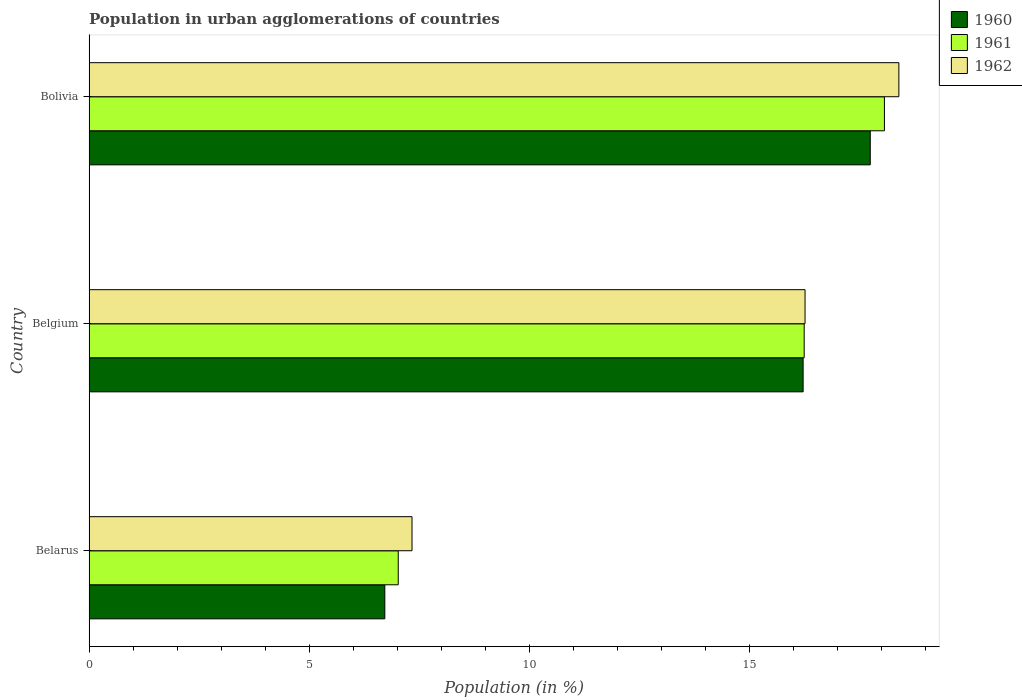How many different coloured bars are there?
Your response must be concise. 3. How many bars are there on the 2nd tick from the top?
Ensure brevity in your answer.  3. How many bars are there on the 2nd tick from the bottom?
Offer a terse response. 3. What is the label of the 3rd group of bars from the top?
Keep it short and to the point. Belarus. What is the percentage of population in urban agglomerations in 1962 in Bolivia?
Keep it short and to the point. 18.4. Across all countries, what is the maximum percentage of population in urban agglomerations in 1961?
Ensure brevity in your answer.  18.07. Across all countries, what is the minimum percentage of population in urban agglomerations in 1962?
Offer a very short reply. 7.34. In which country was the percentage of population in urban agglomerations in 1961 minimum?
Offer a very short reply. Belarus. What is the total percentage of population in urban agglomerations in 1962 in the graph?
Make the answer very short. 41.99. What is the difference between the percentage of population in urban agglomerations in 1960 in Belgium and that in Bolivia?
Provide a short and direct response. -1.53. What is the difference between the percentage of population in urban agglomerations in 1960 in Belarus and the percentage of population in urban agglomerations in 1962 in Belgium?
Ensure brevity in your answer.  -9.55. What is the average percentage of population in urban agglomerations in 1960 per country?
Offer a very short reply. 13.56. What is the difference between the percentage of population in urban agglomerations in 1962 and percentage of population in urban agglomerations in 1961 in Belgium?
Give a very brief answer. 0.02. What is the ratio of the percentage of population in urban agglomerations in 1961 in Belarus to that in Bolivia?
Offer a very short reply. 0.39. Is the percentage of population in urban agglomerations in 1961 in Belarus less than that in Bolivia?
Give a very brief answer. Yes. Is the difference between the percentage of population in urban agglomerations in 1962 in Belarus and Belgium greater than the difference between the percentage of population in urban agglomerations in 1961 in Belarus and Belgium?
Your answer should be very brief. Yes. What is the difference between the highest and the second highest percentage of population in urban agglomerations in 1961?
Your answer should be very brief. 1.82. What is the difference between the highest and the lowest percentage of population in urban agglomerations in 1961?
Provide a short and direct response. 11.04. What does the 2nd bar from the top in Belarus represents?
Ensure brevity in your answer.  1961. Is it the case that in every country, the sum of the percentage of population in urban agglomerations in 1960 and percentage of population in urban agglomerations in 1961 is greater than the percentage of population in urban agglomerations in 1962?
Your answer should be very brief. Yes. How many countries are there in the graph?
Your answer should be very brief. 3. What is the difference between two consecutive major ticks on the X-axis?
Keep it short and to the point. 5. Are the values on the major ticks of X-axis written in scientific E-notation?
Keep it short and to the point. No. Does the graph contain grids?
Make the answer very short. No. What is the title of the graph?
Your response must be concise. Population in urban agglomerations of countries. Does "1987" appear as one of the legend labels in the graph?
Provide a short and direct response. No. What is the Population (in %) of 1960 in Belarus?
Make the answer very short. 6.72. What is the Population (in %) in 1961 in Belarus?
Give a very brief answer. 7.02. What is the Population (in %) in 1962 in Belarus?
Your answer should be compact. 7.34. What is the Population (in %) of 1960 in Belgium?
Ensure brevity in your answer.  16.22. What is the Population (in %) in 1961 in Belgium?
Keep it short and to the point. 16.24. What is the Population (in %) in 1962 in Belgium?
Your answer should be compact. 16.26. What is the Population (in %) in 1960 in Bolivia?
Your answer should be very brief. 17.75. What is the Population (in %) in 1961 in Bolivia?
Your response must be concise. 18.07. What is the Population (in %) of 1962 in Bolivia?
Ensure brevity in your answer.  18.4. Across all countries, what is the maximum Population (in %) in 1960?
Provide a succinct answer. 17.75. Across all countries, what is the maximum Population (in %) in 1961?
Ensure brevity in your answer.  18.07. Across all countries, what is the maximum Population (in %) of 1962?
Provide a succinct answer. 18.4. Across all countries, what is the minimum Population (in %) in 1960?
Ensure brevity in your answer.  6.72. Across all countries, what is the minimum Population (in %) in 1961?
Keep it short and to the point. 7.02. Across all countries, what is the minimum Population (in %) of 1962?
Provide a succinct answer. 7.34. What is the total Population (in %) in 1960 in the graph?
Make the answer very short. 40.68. What is the total Population (in %) in 1961 in the graph?
Your answer should be very brief. 41.33. What is the total Population (in %) of 1962 in the graph?
Provide a short and direct response. 41.99. What is the difference between the Population (in %) of 1960 in Belarus and that in Belgium?
Make the answer very short. -9.5. What is the difference between the Population (in %) of 1961 in Belarus and that in Belgium?
Ensure brevity in your answer.  -9.22. What is the difference between the Population (in %) of 1962 in Belarus and that in Belgium?
Give a very brief answer. -8.93. What is the difference between the Population (in %) in 1960 in Belarus and that in Bolivia?
Offer a terse response. -11.03. What is the difference between the Population (in %) of 1961 in Belarus and that in Bolivia?
Provide a short and direct response. -11.04. What is the difference between the Population (in %) of 1962 in Belarus and that in Bolivia?
Offer a terse response. -11.06. What is the difference between the Population (in %) of 1960 in Belgium and that in Bolivia?
Keep it short and to the point. -1.53. What is the difference between the Population (in %) of 1961 in Belgium and that in Bolivia?
Make the answer very short. -1.82. What is the difference between the Population (in %) in 1962 in Belgium and that in Bolivia?
Give a very brief answer. -2.13. What is the difference between the Population (in %) in 1960 in Belarus and the Population (in %) in 1961 in Belgium?
Your answer should be compact. -9.53. What is the difference between the Population (in %) of 1960 in Belarus and the Population (in %) of 1962 in Belgium?
Make the answer very short. -9.55. What is the difference between the Population (in %) of 1961 in Belarus and the Population (in %) of 1962 in Belgium?
Your answer should be compact. -9.24. What is the difference between the Population (in %) in 1960 in Belarus and the Population (in %) in 1961 in Bolivia?
Offer a very short reply. -11.35. What is the difference between the Population (in %) in 1960 in Belarus and the Population (in %) in 1962 in Bolivia?
Provide a succinct answer. -11.68. What is the difference between the Population (in %) of 1961 in Belarus and the Population (in %) of 1962 in Bolivia?
Your answer should be very brief. -11.37. What is the difference between the Population (in %) in 1960 in Belgium and the Population (in %) in 1961 in Bolivia?
Give a very brief answer. -1.85. What is the difference between the Population (in %) in 1960 in Belgium and the Population (in %) in 1962 in Bolivia?
Keep it short and to the point. -2.18. What is the difference between the Population (in %) of 1961 in Belgium and the Population (in %) of 1962 in Bolivia?
Keep it short and to the point. -2.15. What is the average Population (in %) of 1960 per country?
Provide a succinct answer. 13.56. What is the average Population (in %) of 1961 per country?
Your answer should be compact. 13.78. What is the average Population (in %) of 1962 per country?
Your answer should be very brief. 14. What is the difference between the Population (in %) in 1960 and Population (in %) in 1961 in Belarus?
Keep it short and to the point. -0.3. What is the difference between the Population (in %) of 1960 and Population (in %) of 1962 in Belarus?
Offer a very short reply. -0.62. What is the difference between the Population (in %) of 1961 and Population (in %) of 1962 in Belarus?
Make the answer very short. -0.31. What is the difference between the Population (in %) of 1960 and Population (in %) of 1961 in Belgium?
Keep it short and to the point. -0.02. What is the difference between the Population (in %) of 1960 and Population (in %) of 1962 in Belgium?
Keep it short and to the point. -0.04. What is the difference between the Population (in %) in 1961 and Population (in %) in 1962 in Belgium?
Make the answer very short. -0.02. What is the difference between the Population (in %) of 1960 and Population (in %) of 1961 in Bolivia?
Make the answer very short. -0.32. What is the difference between the Population (in %) of 1960 and Population (in %) of 1962 in Bolivia?
Your answer should be compact. -0.65. What is the difference between the Population (in %) of 1961 and Population (in %) of 1962 in Bolivia?
Offer a terse response. -0.33. What is the ratio of the Population (in %) of 1960 in Belarus to that in Belgium?
Your answer should be compact. 0.41. What is the ratio of the Population (in %) in 1961 in Belarus to that in Belgium?
Ensure brevity in your answer.  0.43. What is the ratio of the Population (in %) of 1962 in Belarus to that in Belgium?
Offer a very short reply. 0.45. What is the ratio of the Population (in %) of 1960 in Belarus to that in Bolivia?
Your response must be concise. 0.38. What is the ratio of the Population (in %) of 1961 in Belarus to that in Bolivia?
Your answer should be compact. 0.39. What is the ratio of the Population (in %) in 1962 in Belarus to that in Bolivia?
Ensure brevity in your answer.  0.4. What is the ratio of the Population (in %) in 1960 in Belgium to that in Bolivia?
Provide a succinct answer. 0.91. What is the ratio of the Population (in %) of 1961 in Belgium to that in Bolivia?
Make the answer very short. 0.9. What is the ratio of the Population (in %) of 1962 in Belgium to that in Bolivia?
Provide a short and direct response. 0.88. What is the difference between the highest and the second highest Population (in %) of 1960?
Give a very brief answer. 1.53. What is the difference between the highest and the second highest Population (in %) of 1961?
Offer a terse response. 1.82. What is the difference between the highest and the second highest Population (in %) in 1962?
Offer a terse response. 2.13. What is the difference between the highest and the lowest Population (in %) in 1960?
Ensure brevity in your answer.  11.03. What is the difference between the highest and the lowest Population (in %) of 1961?
Keep it short and to the point. 11.04. What is the difference between the highest and the lowest Population (in %) in 1962?
Offer a very short reply. 11.06. 